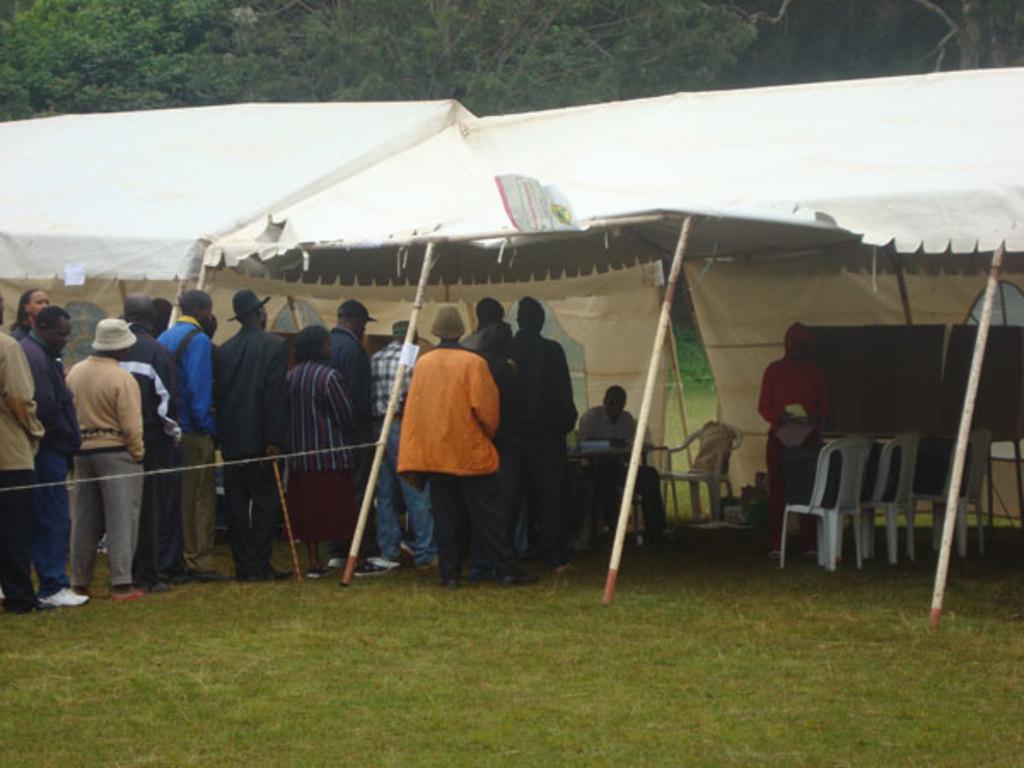Could you give a brief overview of what you see in this image? In this image i can see group of people standing in a queue and i can see a person sitting on the chair. In the background i can see few trees, few tents, a person standing in a red dress, few empty chairs and the grass. 